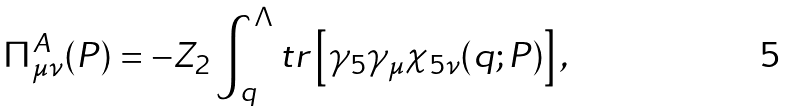<formula> <loc_0><loc_0><loc_500><loc_500>\Pi ^ { A } _ { \mu \nu } ( P ) = - Z _ { 2 } \int ^ { \Lambda } _ { q } t r \left [ \gamma _ { 5 } \gamma _ { \mu } \chi _ { 5 \nu } ( q ; P ) \right ] ,</formula> 